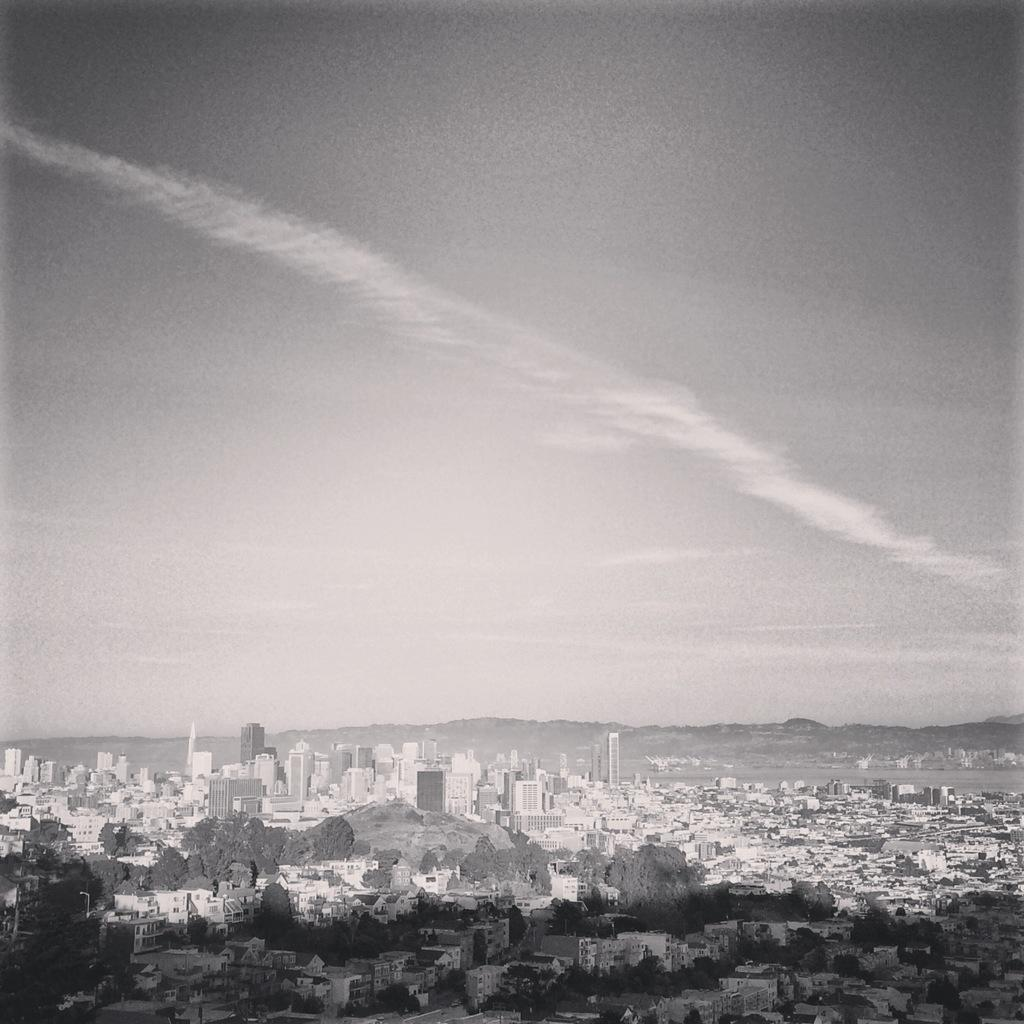What type of structures can be seen in the image? There are buildings in the image. What other natural elements are present in the image? There are trees in the image. What part of the natural environment is visible in the image? The sky is visible in the image. How is the image presented in terms of color? The image is in black and white mode. What type of bell can be heard ringing in the image? There is no bell present in the image, and therefore no sound can be heard. What kind of stone is visible in the image? There is no stone visible in the image; it features buildings, trees, and the sky. 